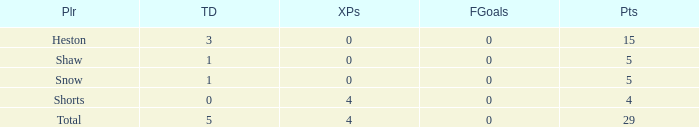What is the sum of all the touchdowns when the player had more than 0 extra points and less than 0 field goals? None. 